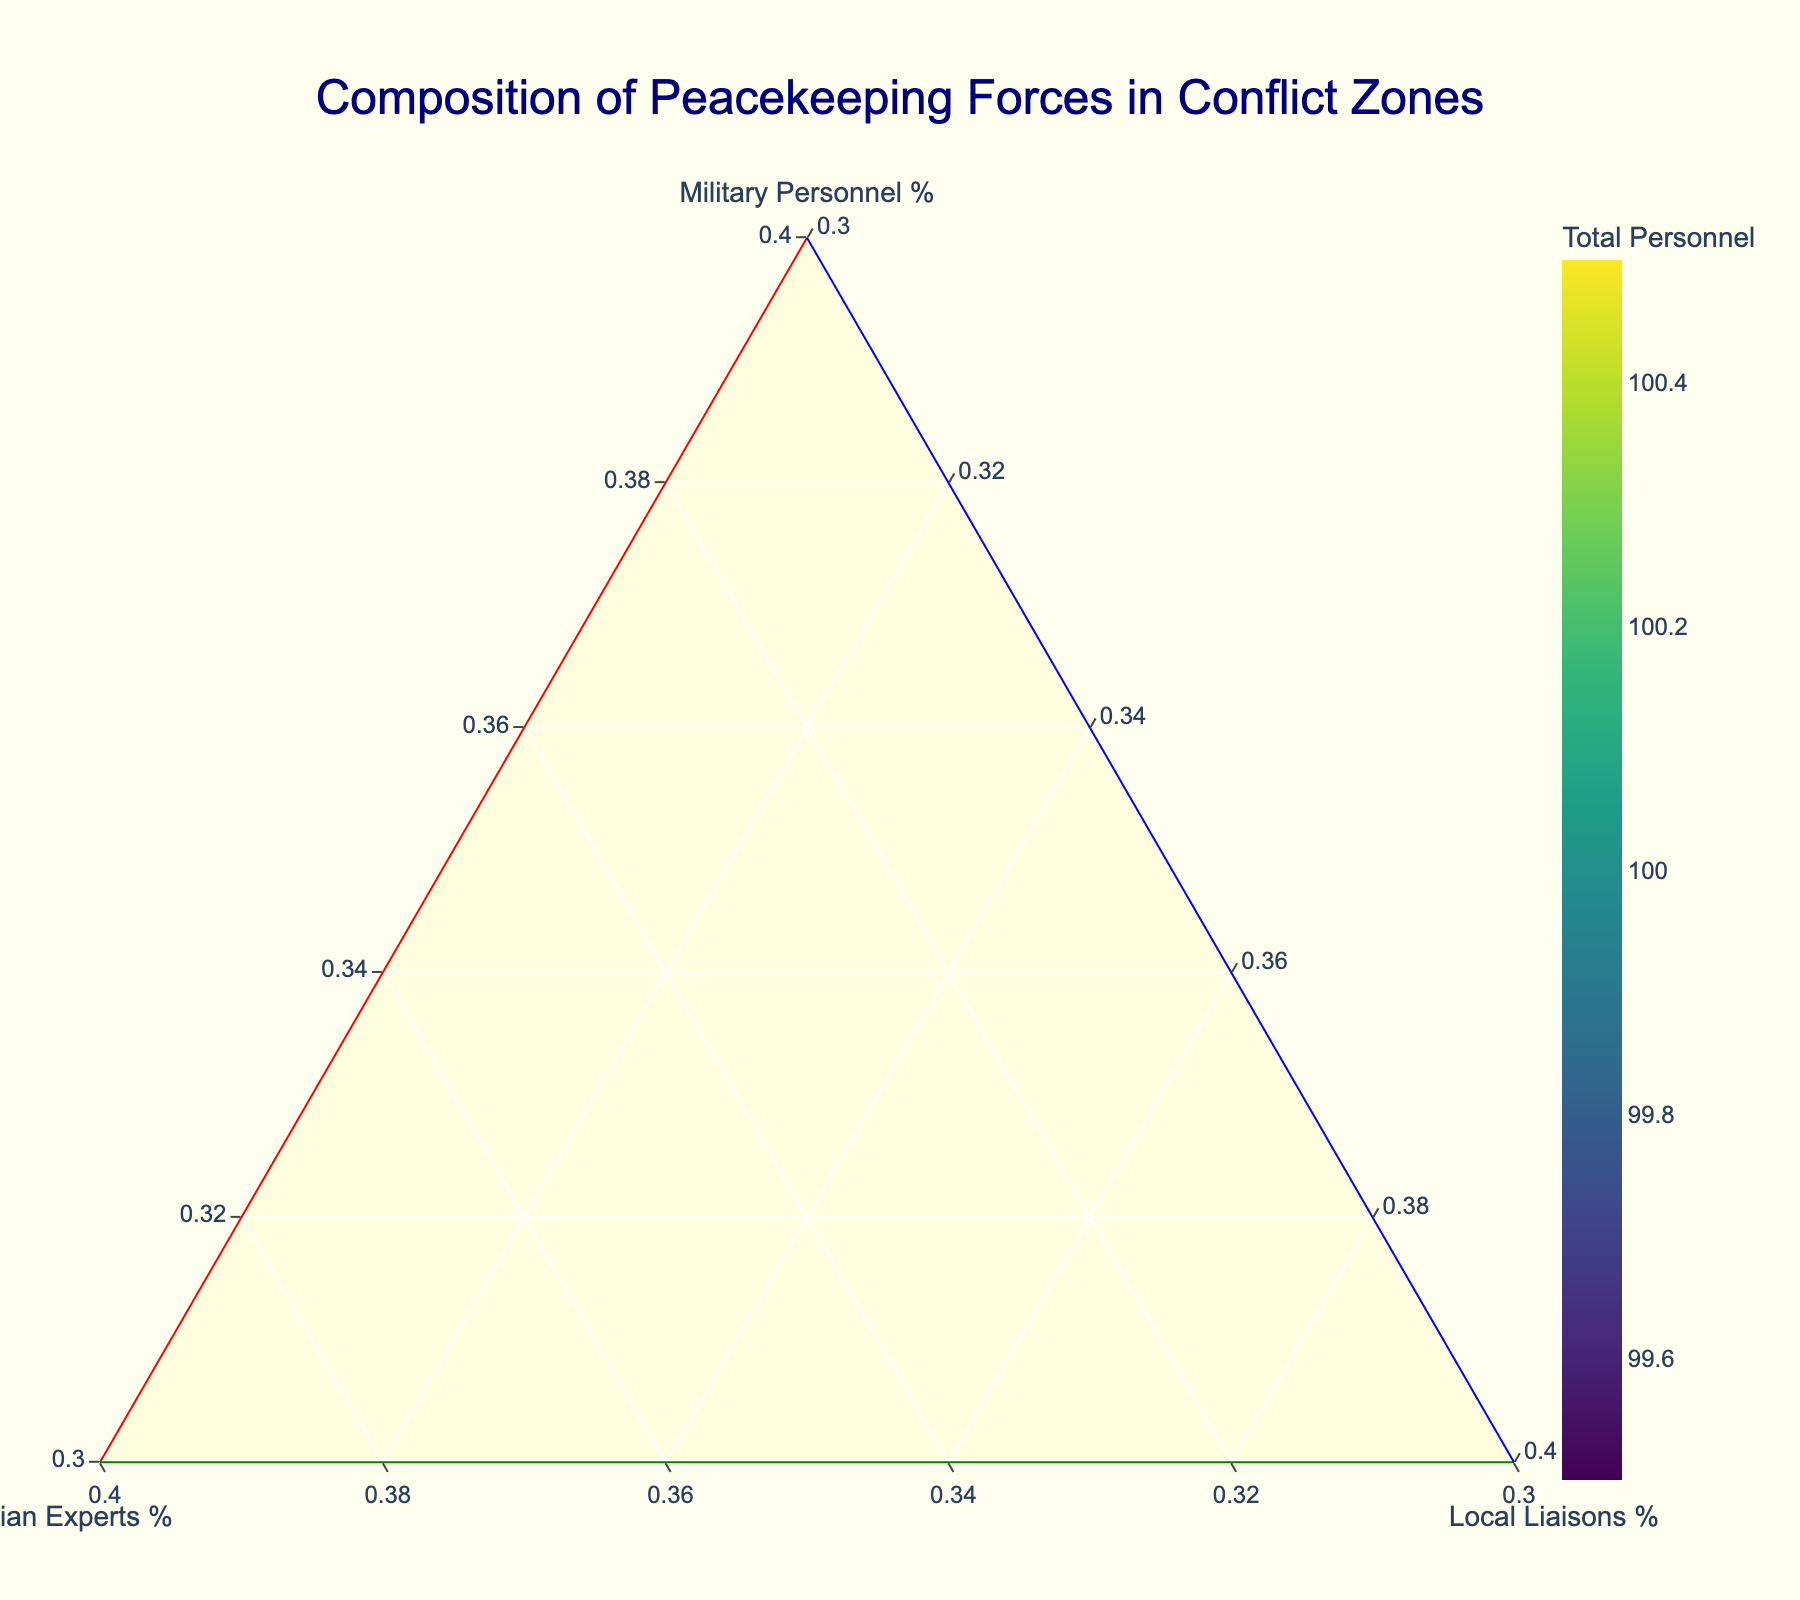Which region has the highest percentage of military personnel? The figure shows regions plotted on a ternary plot, and among these, the region positioned closest to the 'Military Personnel %' axis has the highest percentage of military personnel. This position corresponds to Afghanistan.
Answer: Afghanistan Which region has the highest total number of personnel? The figure uses the size and color of the markers to represent the total number of personnel. The region with the largest and darkest marker represents the highest total personnel, which is Afghanistan.
Answer: Afghanistan How does the composition of Kosovo's peacekeeping forces compare with that of Afghanistan? Kosovo is placed closer to the 'Civilian Experts %' axis and further from the 'Military Personnel %' axis. In contrast, Afghanistan is positioned closest to the 'Military Personnel %' axis. This means Kosovo has a higher percentage of civilian experts, while Afghanistan has a higher percentage of military personnel.
Answer: Kosovo has more civilian experts; Afghanistan has more military personnel Which regions have equal percentages of local liaisons? Regions positioned along the horizontal line passing through 'Local Liaisons %' will have the same percentage. South Sudan, Eastern Ukraine, Mali, Lebanon, Central African Republic, Kosovo, Haiti have 15%, and Syria, Yemen, Libya, Myanmar, Colombia have 20%, Democratic Republic of Congo, Somalia, and Afghanistan have 10%.
Answer: South Sudan, Eastern Ukraine, Mali, Lebanon, Central African Republic, Kosovo, Haiti (15%), Syria, Yemen, Libya, Myanmar, Colombia (20%), Democratic Republic of Congo, Somalia, Afghanistan (10%) What region is closest to having an equal distribution among military personnel, civilian experts, and local liaisons? The region nearest the center point of the ternary plot represents an equal distribution. In this case, no region falls exactly at the center, but Colombia is closest.
Answer: Colombia What percentage of civilian experts does Lebanon have? The region’s position closer to the 'Civilian Experts %' axis and the axis title provides a clear indication. Lebanon is situated near the 35% mark on the 'Civilian Experts %' axis.
Answer: 35% Which regions are most and least reliant on local liaisons? The bottom corner of the ternary plot represents local liaisons. The region furthest to the left on this scale (with the least reliance) is the Democratic Republic of Congo (10%). The region at the bottom right (with the most reliance) in relative terms, are Syria, Yemen, Libya, Myanmar, and Colombia (20%).
Answer: Most: Syria, Yemen, Libya, Myanmar, Colombia; Least: Democratic Republic of Congo 